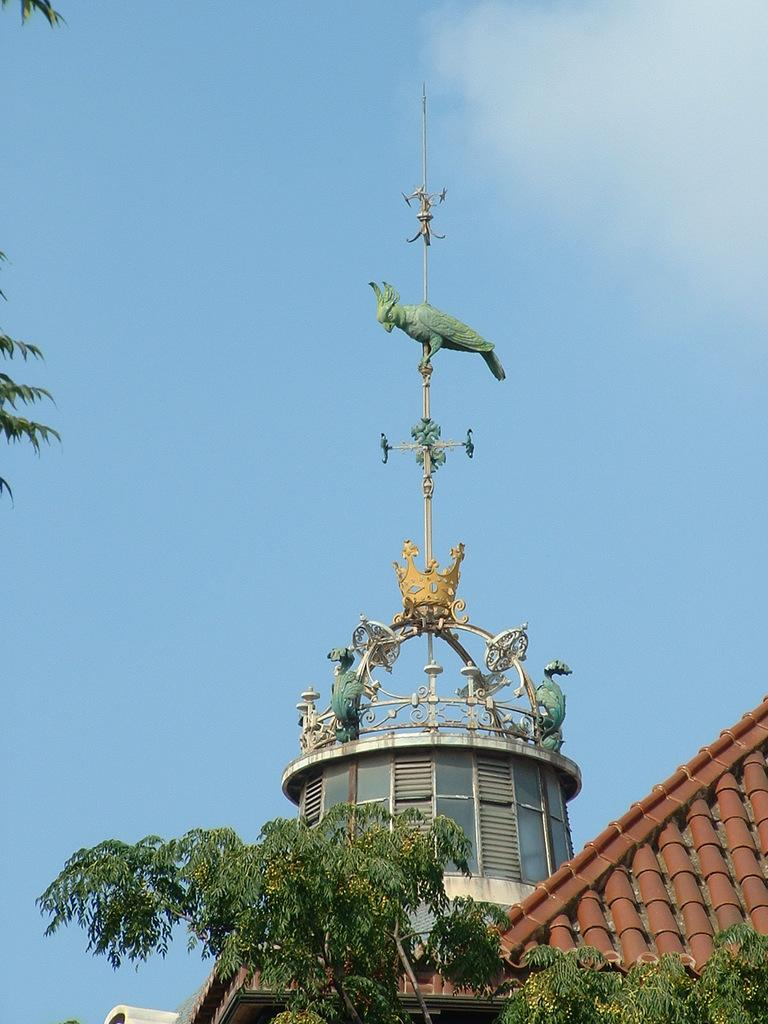What type of structure is present in the image? There is a building in the image. What is the color of the building? The building is brown in color. What other natural elements can be seen in the image? There are trees in the image. What is the color of the trees? The trees are green in color. What part of the natural environment is visible in the image? The sky is visible in the image. What is the color of the sky? The sky is blue in color. What type of reaction can be observed in the building in the image? There is no reaction to observe in the building, as it is a static structure. What type of birth is depicted in the image? There is no birth depicted in the image; it features a building, trees, and the sky. 